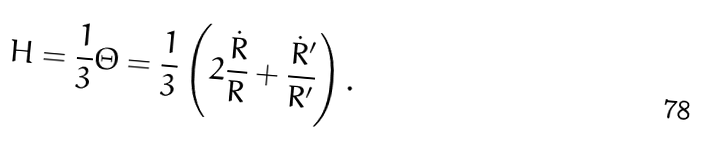<formula> <loc_0><loc_0><loc_500><loc_500>H = \frac { 1 } { 3 } \Theta = \frac { 1 } { 3 } \left ( 2 \frac { \dot { R } } { R } + \frac { \dot { R } ^ { \prime } } { R ^ { \prime } } \right ) .</formula> 